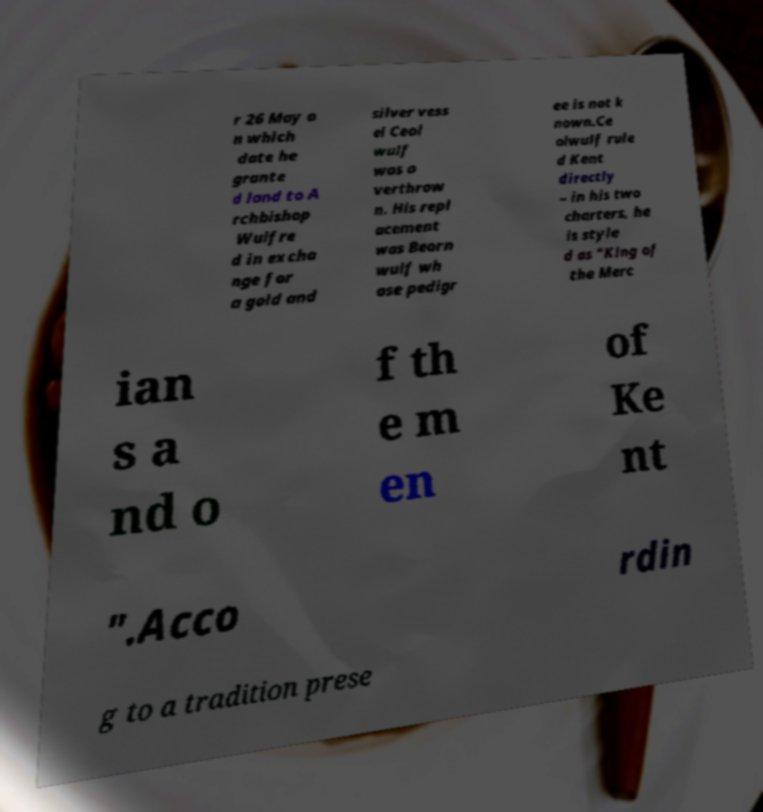Could you assist in decoding the text presented in this image and type it out clearly? r 26 May o n which date he grante d land to A rchbishop Wulfre d in excha nge for a gold and silver vess el Ceol wulf was o verthrow n. His repl acement was Beorn wulf wh ose pedigr ee is not k nown.Ce olwulf rule d Kent directly – in his two charters, he is style d as "King of the Merc ian s a nd o f th e m en of Ke nt ".Acco rdin g to a tradition prese 